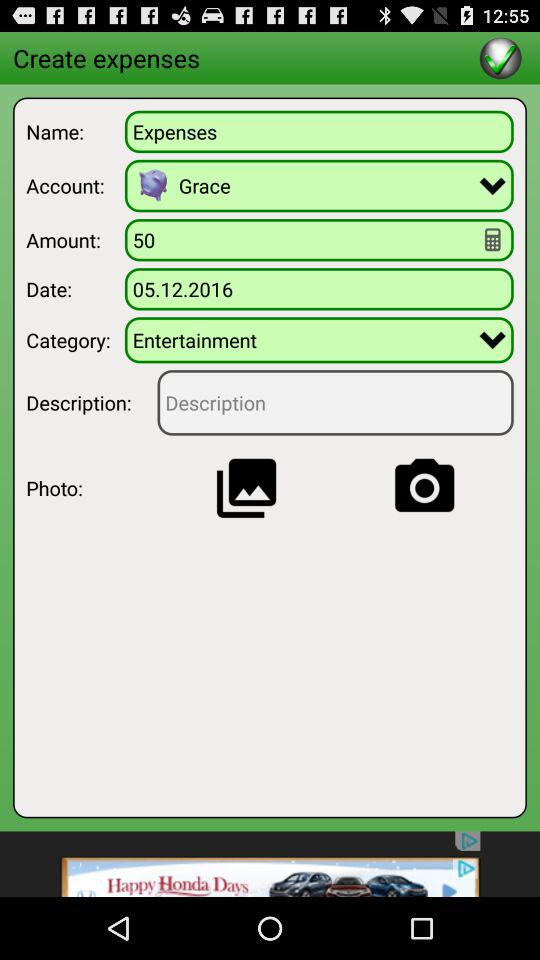What is the count of the amount? The amount has a count of 50. 